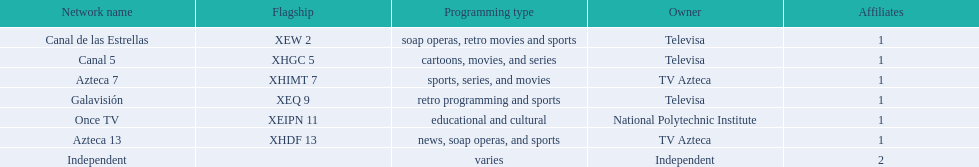Can you give me this table as a dict? {'header': ['Network name', 'Flagship', 'Programming type', 'Owner', 'Affiliates'], 'rows': [['Canal de las Estrellas', 'XEW 2', 'soap operas, retro movies and sports', 'Televisa', '1'], ['Canal 5', 'XHGC 5', 'cartoons, movies, and series', 'Televisa', '1'], ['Azteca 7', 'XHIMT 7', 'sports, series, and movies', 'TV Azteca', '1'], ['Galavisión', 'XEQ 9', 'retro programming and sports', 'Televisa', '1'], ['Once TV', 'XEIPN 11', 'educational and cultural', 'National Polytechnic Institute', '1'], ['Azteca 13', 'XHDF 13', 'news, soap operas, and sports', 'TV Azteca', '1'], ['Independent', '', 'varies', 'Independent', '2']]} How many networks are under televisa's ownership? 3. 